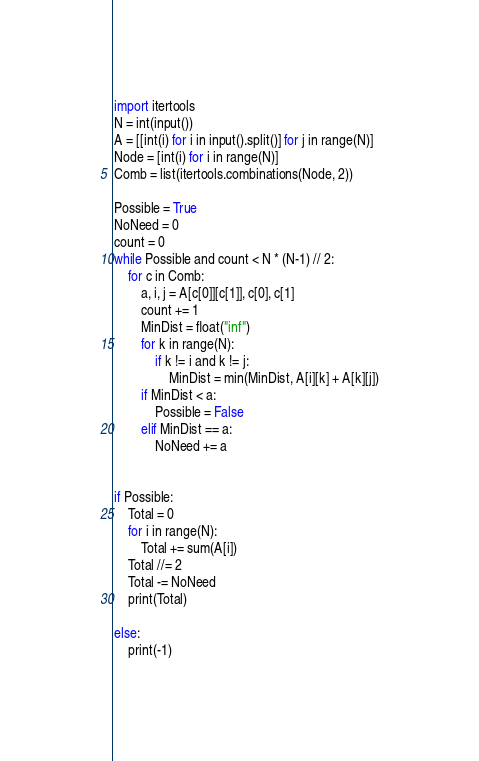Convert code to text. <code><loc_0><loc_0><loc_500><loc_500><_Python_>import itertools
N = int(input())
A = [[int(i) for i in input().split()] for j in range(N)]
Node = [int(i) for i in range(N)]
Comb = list(itertools.combinations(Node, 2))

Possible = True
NoNeed = 0
count = 0
while Possible and count < N * (N-1) // 2:
    for c in Comb:
        a, i, j = A[c[0]][c[1]], c[0], c[1]
        count += 1
        MinDist = float("inf")
        for k in range(N):
            if k != i and k != j:
                MinDist = min(MinDist, A[i][k] + A[k][j])
        if MinDist < a:
            Possible = False
        elif MinDist == a:
            NoNeed += a
        

if Possible:
    Total = 0
    for i in range(N):
        Total += sum(A[i])
    Total //= 2
    Total -= NoNeed
    print(Total)

else:
    print(-1)</code> 